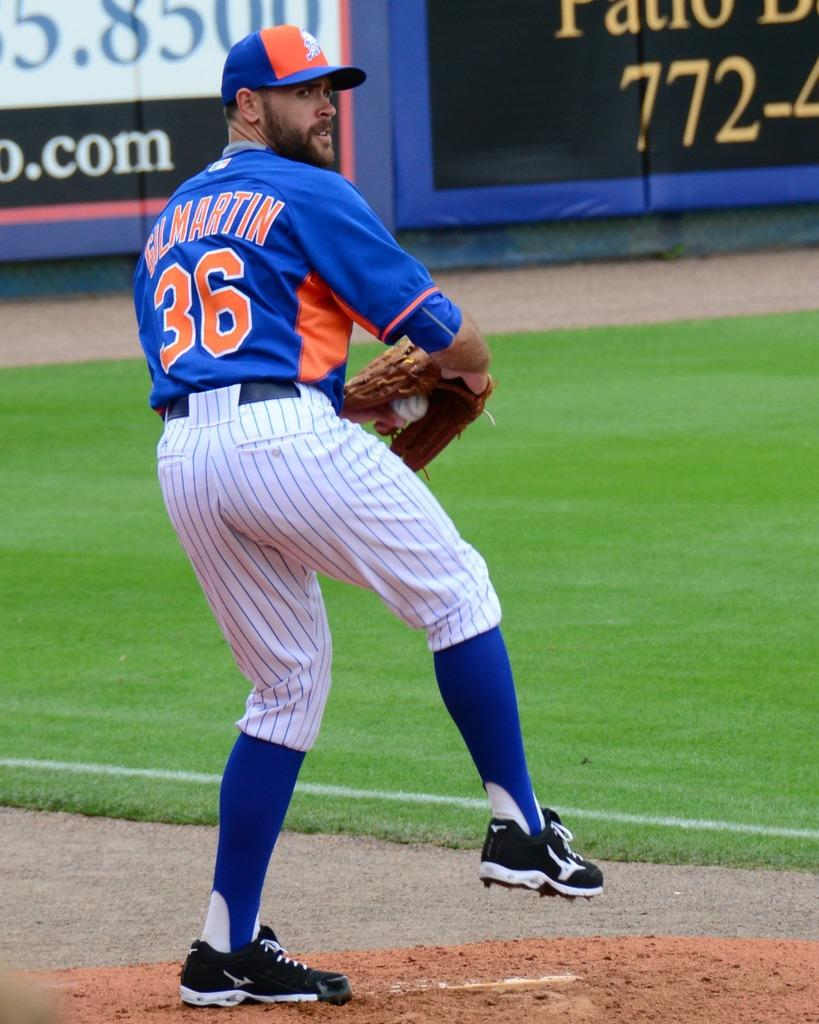<image>
Describe the image concisely. A baseball player is rearing up to throw the ball. His shirt says "Gilmartin 36." 